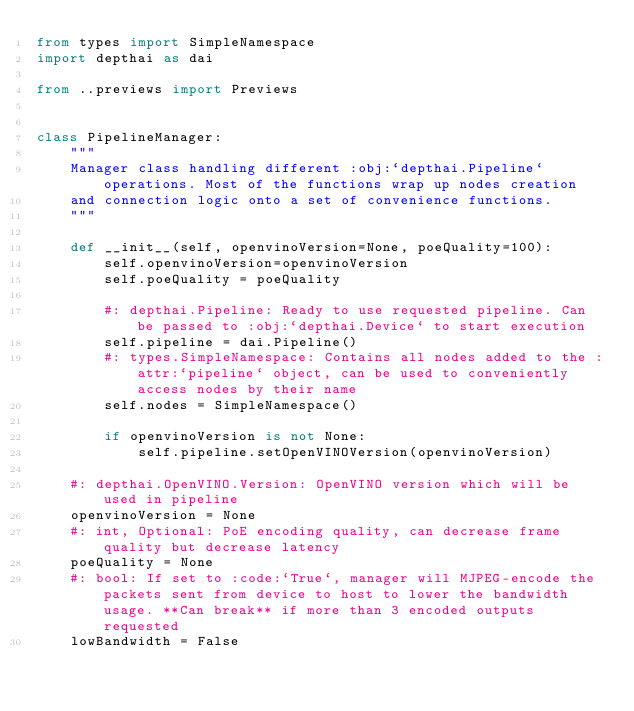<code> <loc_0><loc_0><loc_500><loc_500><_Python_>from types import SimpleNamespace
import depthai as dai

from ..previews import Previews


class PipelineManager:
    """
    Manager class handling different :obj:`depthai.Pipeline` operations. Most of the functions wrap up nodes creation
    and connection logic onto a set of convenience functions.
    """

    def __init__(self, openvinoVersion=None, poeQuality=100):
        self.openvinoVersion=openvinoVersion
        self.poeQuality = poeQuality

        #: depthai.Pipeline: Ready to use requested pipeline. Can be passed to :obj:`depthai.Device` to start execution
        self.pipeline = dai.Pipeline()
        #: types.SimpleNamespace: Contains all nodes added to the :attr:`pipeline` object, can be used to conveniently access nodes by their name
        self.nodes = SimpleNamespace()

        if openvinoVersion is not None:
            self.pipeline.setOpenVINOVersion(openvinoVersion)

    #: depthai.OpenVINO.Version: OpenVINO version which will be used in pipeline
    openvinoVersion = None
    #: int, Optional: PoE encoding quality, can decrease frame quality but decrease latency
    poeQuality = None
    #: bool: If set to :code:`True`, manager will MJPEG-encode the packets sent from device to host to lower the bandwidth usage. **Can break** if more than 3 encoded outputs requested
    lowBandwidth = False
</code> 